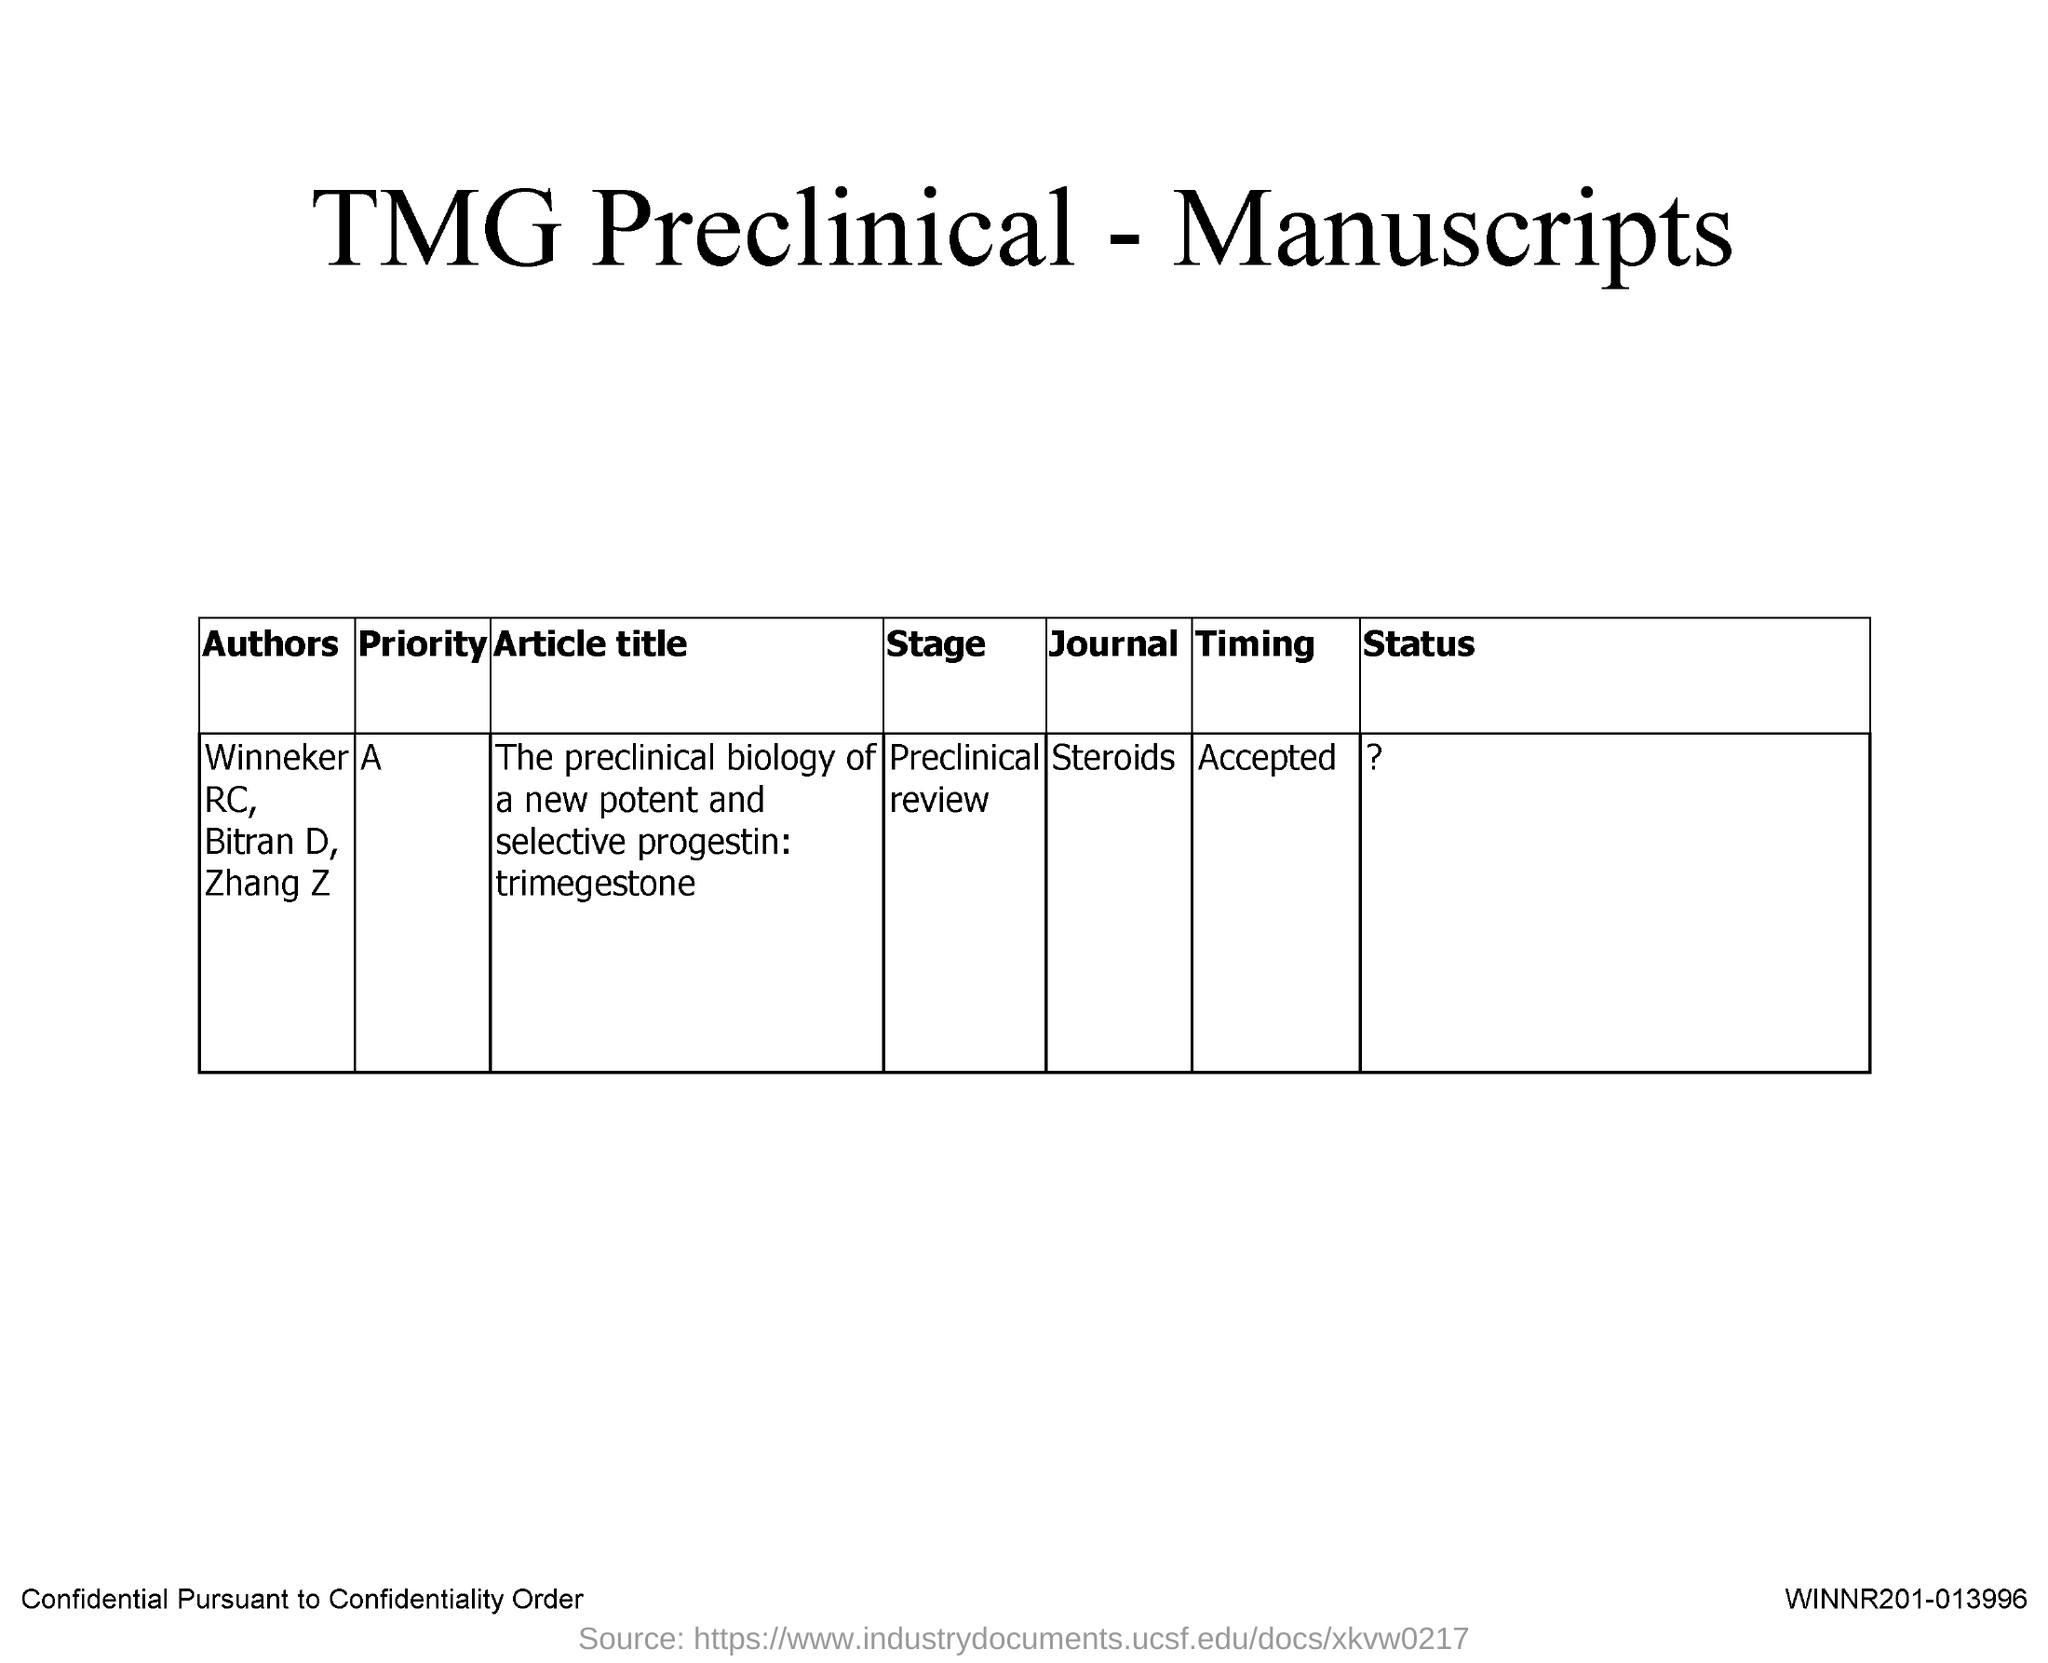Give some essential details in this illustration. The name of the journal is Steroids. 